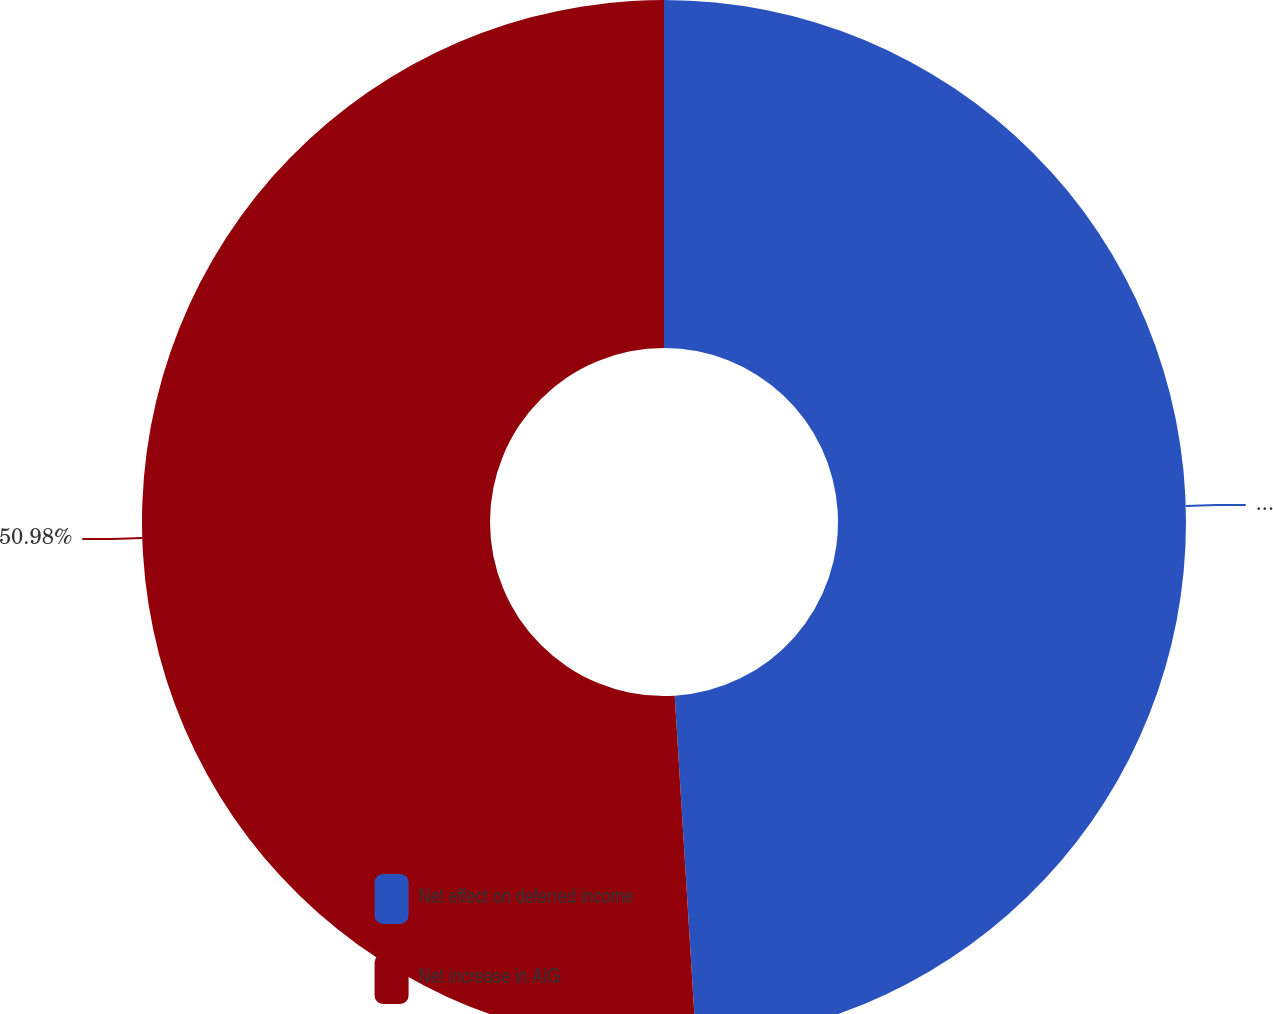<chart> <loc_0><loc_0><loc_500><loc_500><pie_chart><fcel>Net effect on deferred income<fcel>Net increase in AIG<nl><fcel>49.02%<fcel>50.98%<nl></chart> 